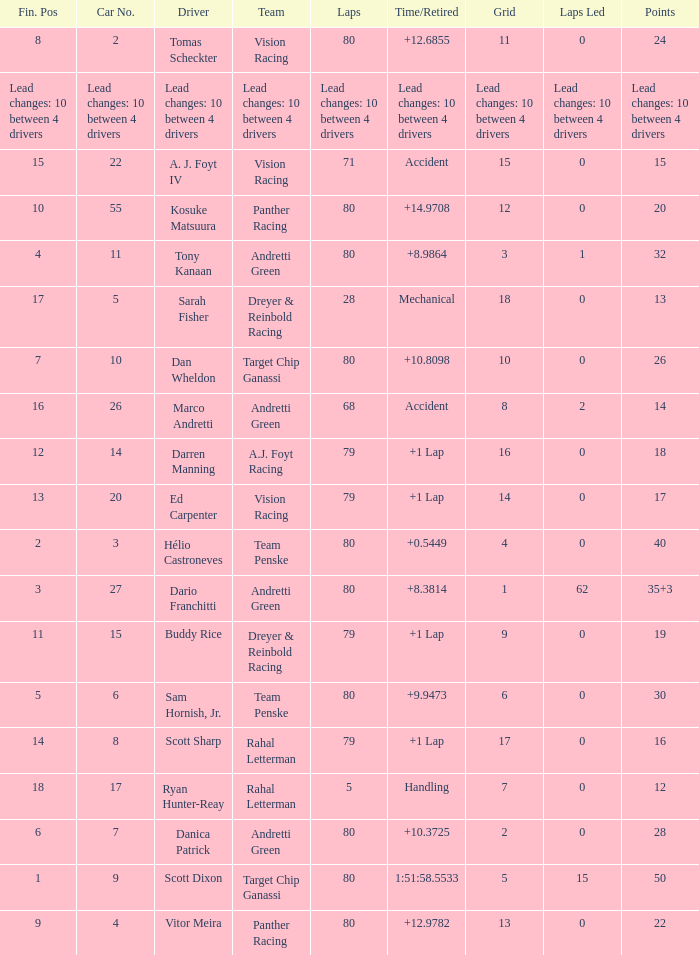What grid has 24 points? 11.0. 